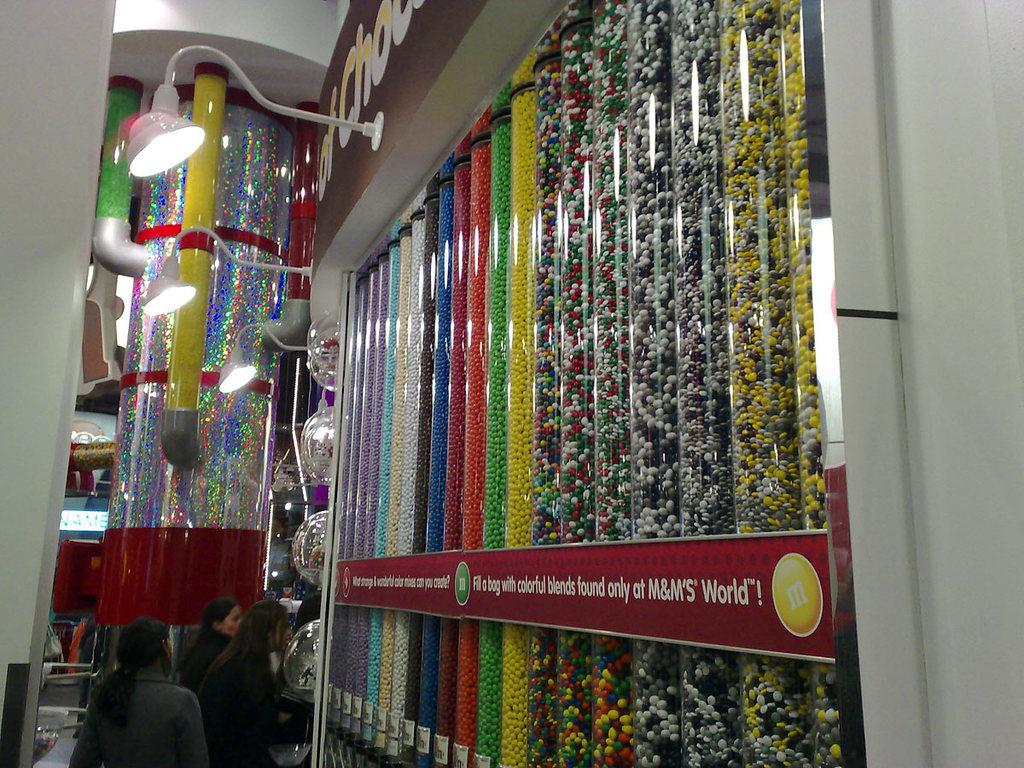<image>
Give a short and clear explanation of the subsequent image. An establishment called M&M'S World carries unusual candy varieties. 